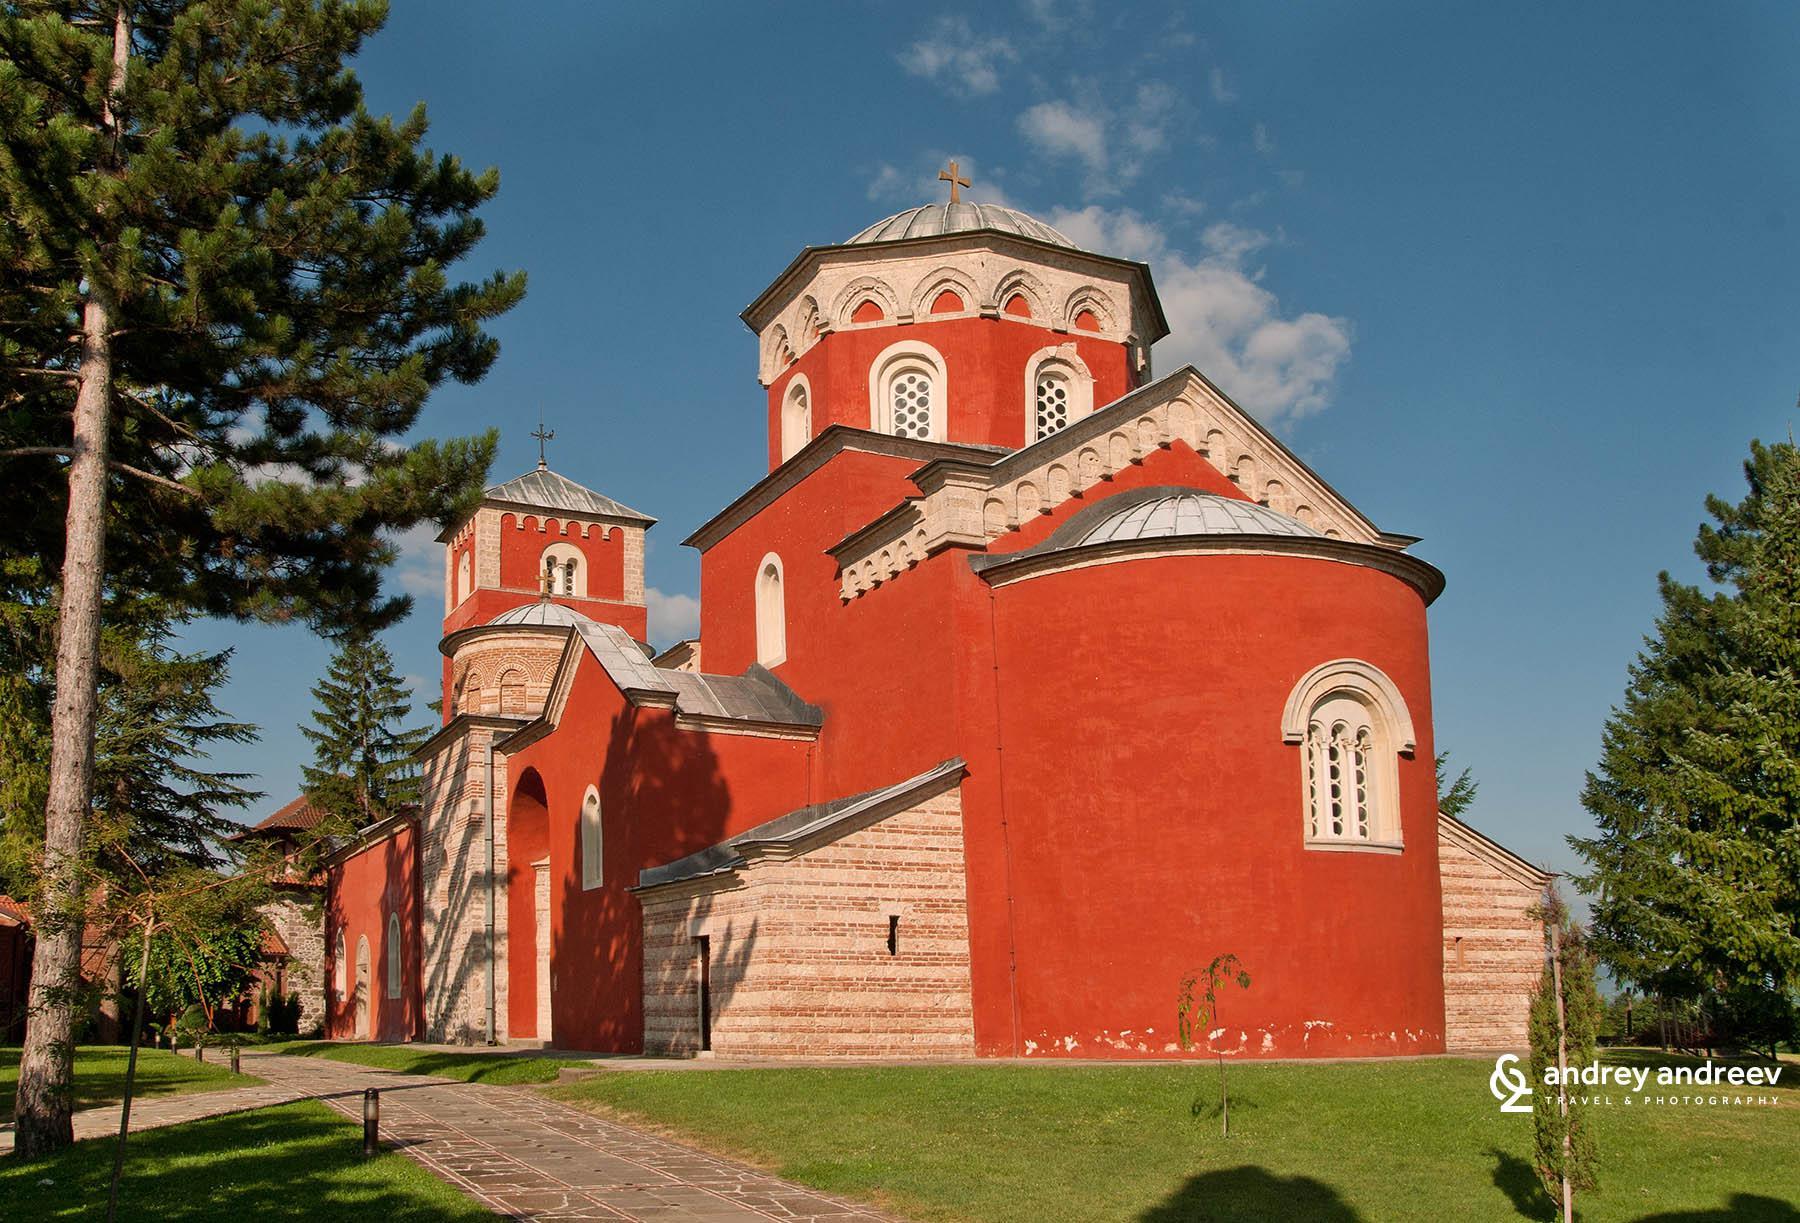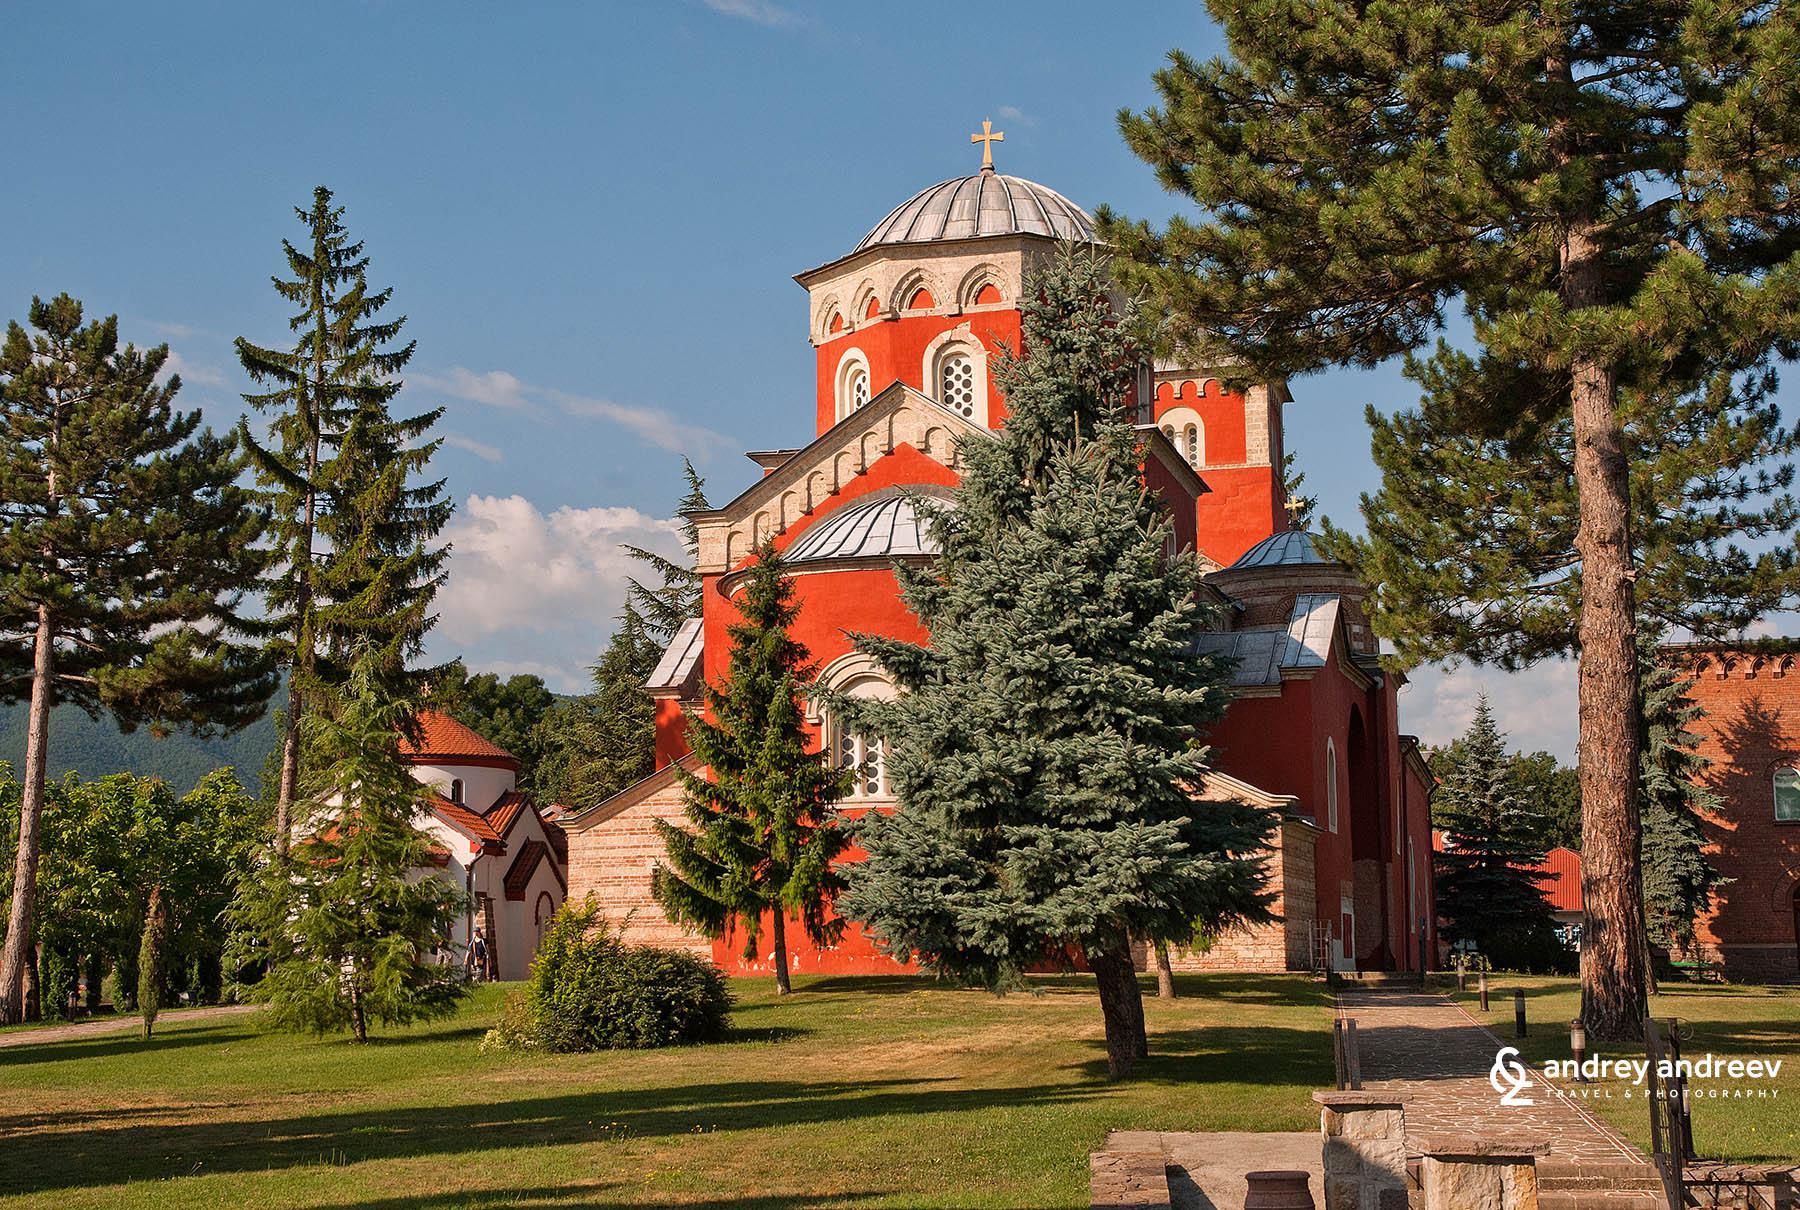The first image is the image on the left, the second image is the image on the right. For the images displayed, is the sentence "Left image shows sprawling architecture with an orange domed semi-cylinder flanked by peak-roofed brown structures facing the camera." factually correct? Answer yes or no. Yes. 